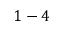Convert formula to latex. <formula><loc_0><loc_0><loc_500><loc_500>1 - 4</formula> 